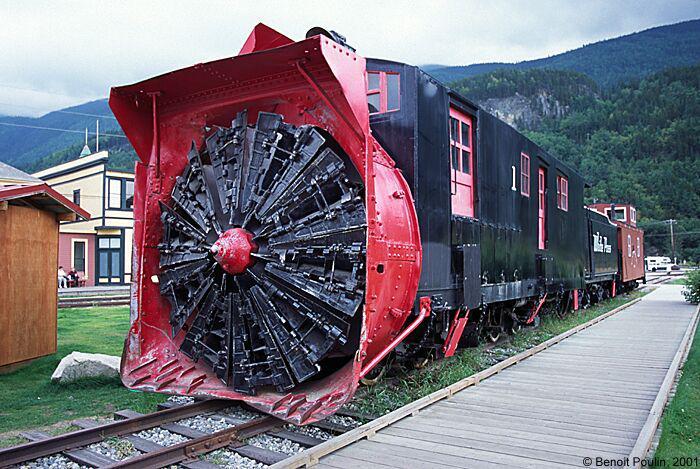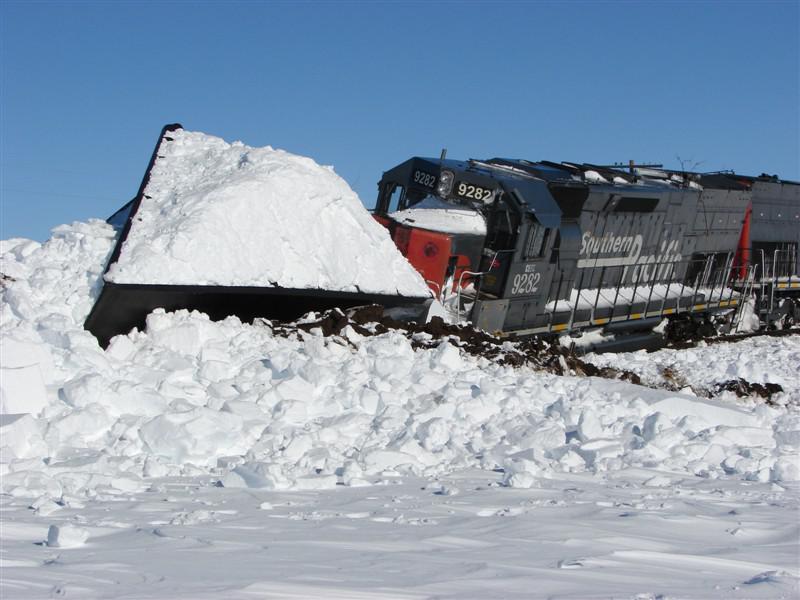The first image is the image on the left, the second image is the image on the right. Analyze the images presented: Is the assertion "Snow covers the area in each of the images." valid? Answer yes or no. No. The first image is the image on the left, the second image is the image on the right. For the images displayed, is the sentence "The left and right image contains the same number of black trains." factually correct? Answer yes or no. Yes. 